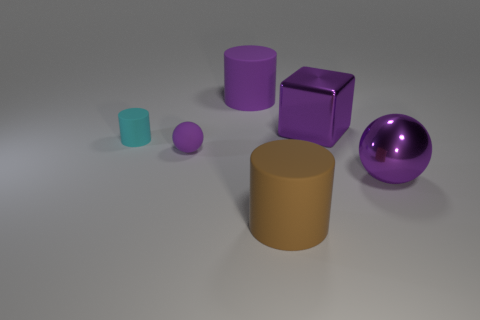Subtract all purple balls. How many were subtracted if there are1purple balls left? 1 Add 3 big purple matte cylinders. How many objects exist? 9 Subtract all small cyan cylinders. How many cylinders are left? 2 Subtract all purple cylinders. How many cylinders are left? 2 Subtract all cubes. How many objects are left? 5 Subtract 2 spheres. How many spheres are left? 0 Add 2 small objects. How many small objects exist? 4 Subtract 1 brown cylinders. How many objects are left? 5 Subtract all cyan spheres. Subtract all yellow cubes. How many spheres are left? 2 Subtract all purple blocks. How many blue cylinders are left? 0 